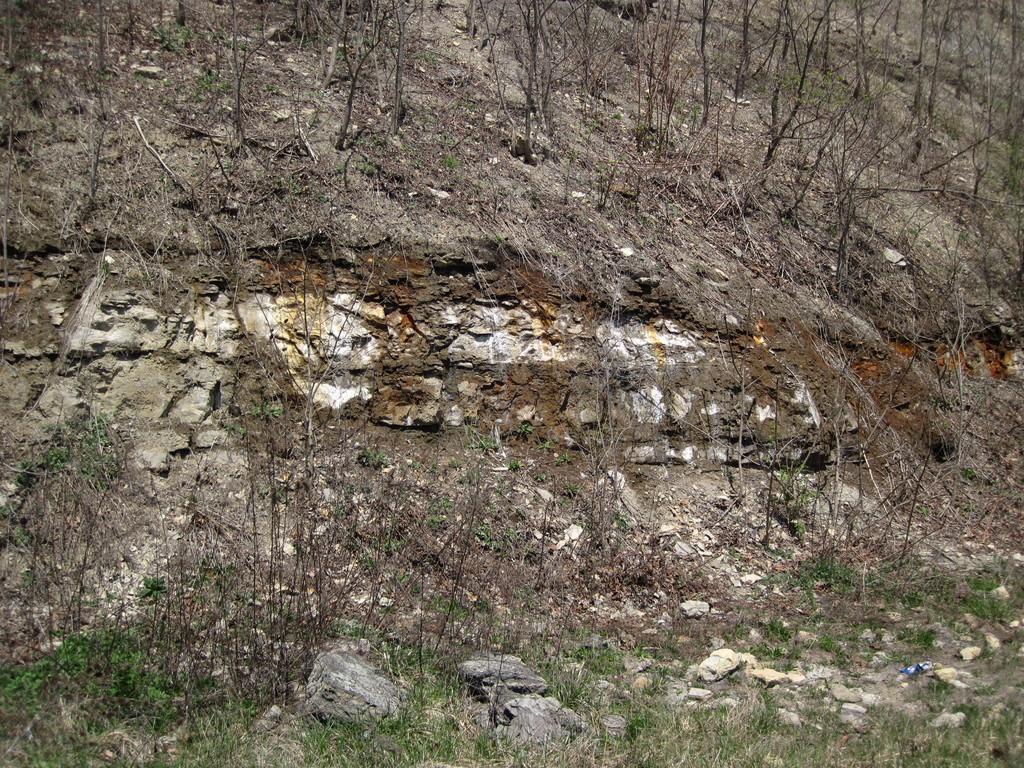Could you give a brief overview of what you see in this image? In this image we can see a ground on which group of trees ,stones are present. 